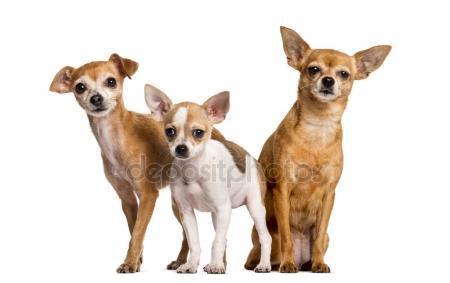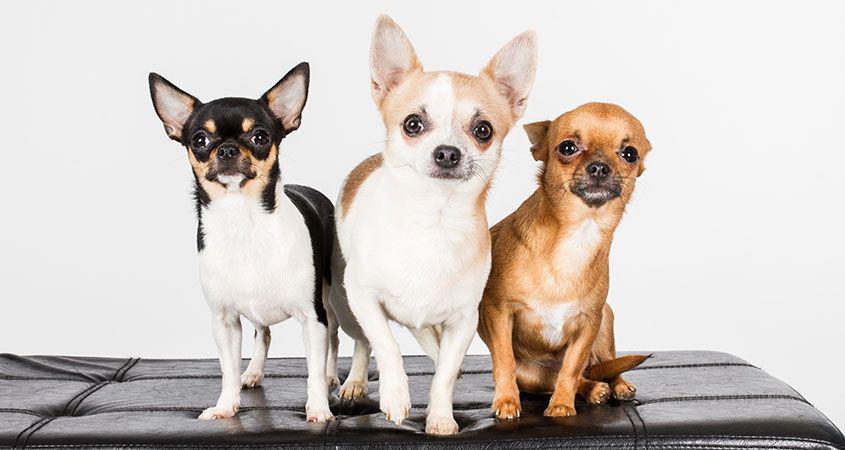The first image is the image on the left, the second image is the image on the right. Assess this claim about the two images: "There are more dogs in the image on the right.". Correct or not? Answer yes or no. No. The first image is the image on the left, the second image is the image on the right. Analyze the images presented: Is the assertion "One image contains three small dogs, and the other image contains four small dogs." valid? Answer yes or no. No. 